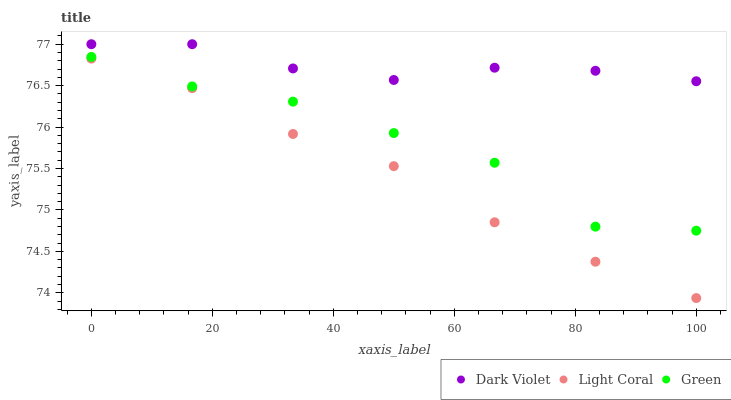Does Light Coral have the minimum area under the curve?
Answer yes or no. Yes. Does Dark Violet have the maximum area under the curve?
Answer yes or no. Yes. Does Green have the minimum area under the curve?
Answer yes or no. No. Does Green have the maximum area under the curve?
Answer yes or no. No. Is Light Coral the smoothest?
Answer yes or no. Yes. Is Green the roughest?
Answer yes or no. Yes. Is Dark Violet the smoothest?
Answer yes or no. No. Is Dark Violet the roughest?
Answer yes or no. No. Does Light Coral have the lowest value?
Answer yes or no. Yes. Does Green have the lowest value?
Answer yes or no. No. Does Dark Violet have the highest value?
Answer yes or no. Yes. Does Green have the highest value?
Answer yes or no. No. Is Light Coral less than Green?
Answer yes or no. Yes. Is Dark Violet greater than Light Coral?
Answer yes or no. Yes. Does Light Coral intersect Green?
Answer yes or no. No. 